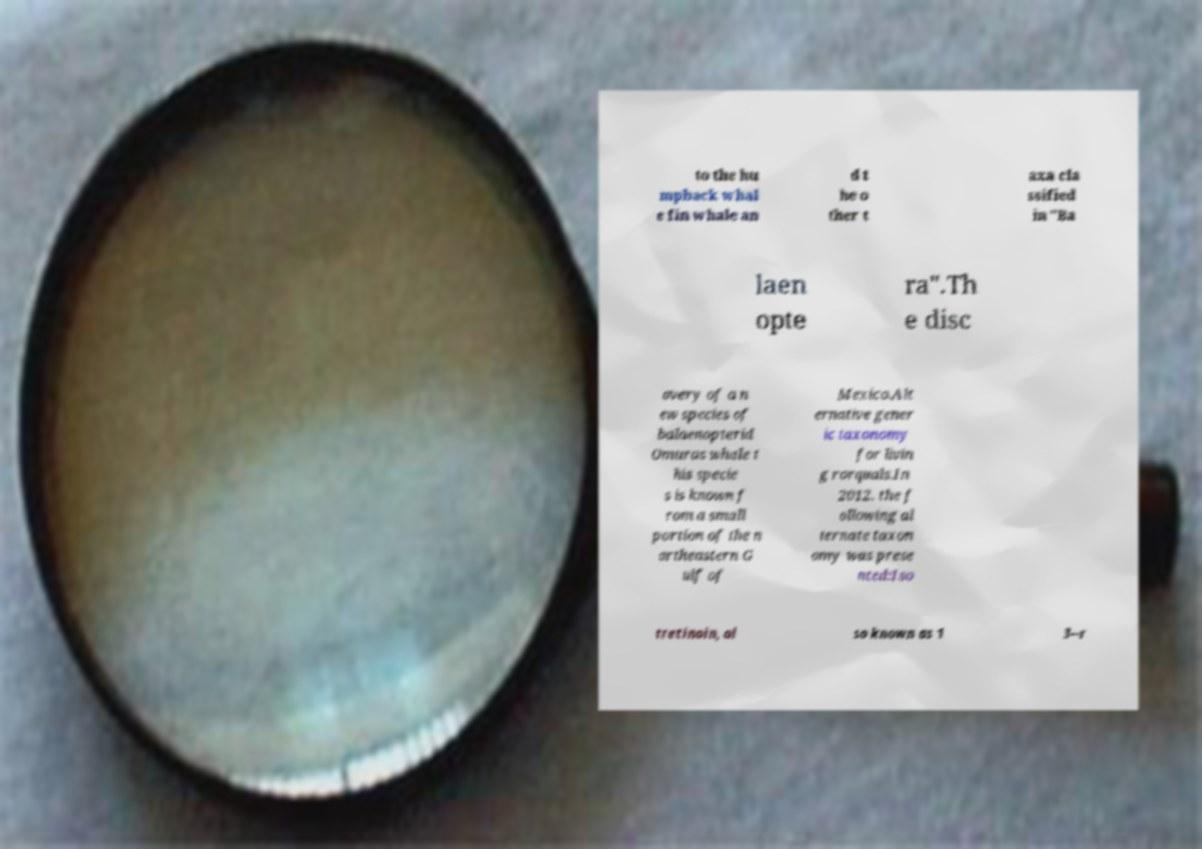Please identify and transcribe the text found in this image. to the hu mpback whal e fin whale an d t he o ther t axa cla ssified in "Ba laen opte ra".Th e disc overy of a n ew species of balaenopterid Omuras whale t his specie s is known f rom a small portion of the n ortheastern G ulf of Mexico.Alt ernative gener ic taxonomy for livin g rorquals.In 2012, the f ollowing al ternate taxon omy was prese nted:Iso tretinoin, al so known as 1 3--r 